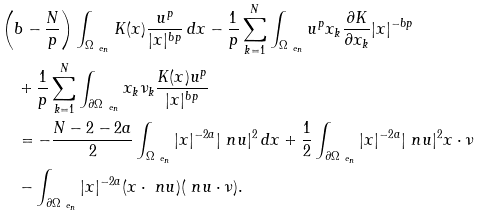<formula> <loc_0><loc_0><loc_500><loc_500>& \left ( b - \frac { N } { p } \right ) \int _ { \Omega _ { \ e _ { n } } } K ( x ) \frac { u ^ { p } } { | x | ^ { b p } } \, d x - \frac { 1 } { p } \sum _ { k = 1 } ^ { N } \int _ { \Omega _ { \ e _ { n } } } u ^ { p } x _ { k } \frac { \partial K } { \partial x _ { k } } | x | ^ { - b p } \\ & \quad + \frac { 1 } { p } \sum _ { k = 1 } ^ { N } \int _ { \partial \Omega _ { \ e _ { n } } } x _ { k } \nu _ { k } \frac { K ( x ) u ^ { p } } { | x | ^ { b p } } \\ & \quad = - \frac { N - 2 - 2 a } 2 \int _ { \Omega _ { \ e _ { n } } } | x | ^ { - 2 a } | \ n u | ^ { 2 } \, d x + \frac { 1 } { 2 } \int _ { \partial \Omega _ { \ e _ { n } } } | x | ^ { - 2 a } | \ n u | ^ { 2 } x \cdot \nu \\ & \quad - \int _ { \partial \Omega _ { \ e _ { n } } } | x | ^ { - 2 a } ( x \cdot \ n u ) ( \ n u \cdot \nu ) .</formula> 